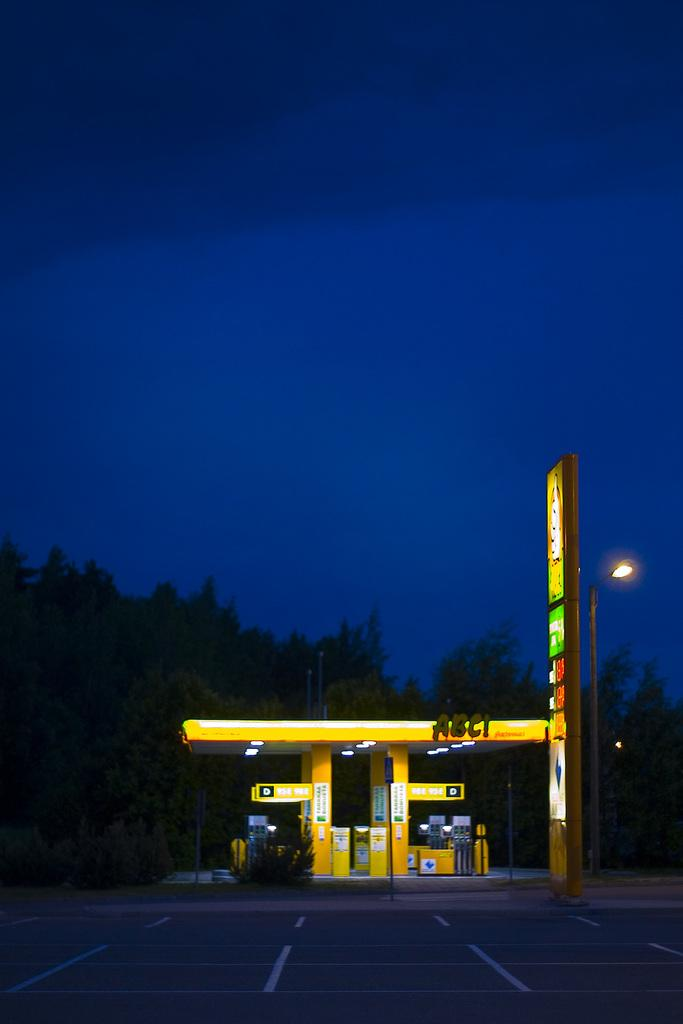<image>
Summarize the visual content of the image. A gas station that is called ABC! with a parking lot in front of it. 